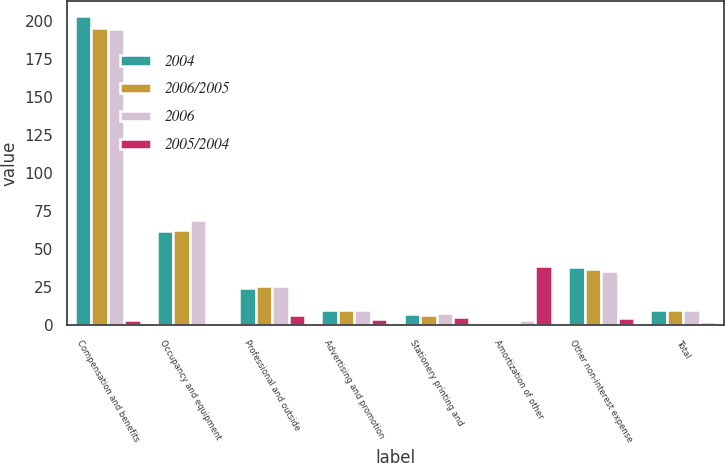<chart> <loc_0><loc_0><loc_500><loc_500><stacked_bar_chart><ecel><fcel>Compensation and benefits<fcel>Occupancy and equipment<fcel>Professional and outside<fcel>Advertising and promotion<fcel>Stationery printing and<fcel>Amortization of other<fcel>Other non-interest expense<fcel>Total<nl><fcel>2004<fcel>202.9<fcel>62.2<fcel>24.3<fcel>10.3<fcel>7.5<fcel>1.1<fcel>38.6<fcel>9.9<nl><fcel>2006/2005<fcel>195.5<fcel>62.4<fcel>26.1<fcel>9.9<fcel>7.1<fcel>1.8<fcel>36.9<fcel>9.9<nl><fcel>2006<fcel>194.3<fcel>69.3<fcel>25.8<fcel>9.8<fcel>8<fcel>3.4<fcel>35.7<fcel>9.9<nl><fcel>2005/2004<fcel>3.8<fcel>0.3<fcel>6.9<fcel>4<fcel>5.6<fcel>38.9<fcel>4.6<fcel>2.1<nl></chart> 